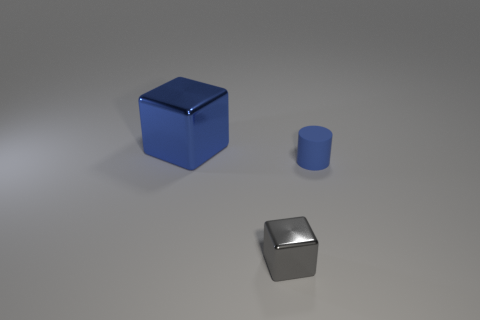Can you describe the texture and material of the objects shown in the image? Certainly! The objects in the image appear to have smooth and reflective surfaces. The two cubes, one large and blue, the other smaller and metallic, seem to be made of materials like painted metal or plastic for the blue cube, and possibly polished steel or aluminum for the metallic cube. The small cylinder shares the blue cube's color and reflective texture, suggesting a similar material composition. 